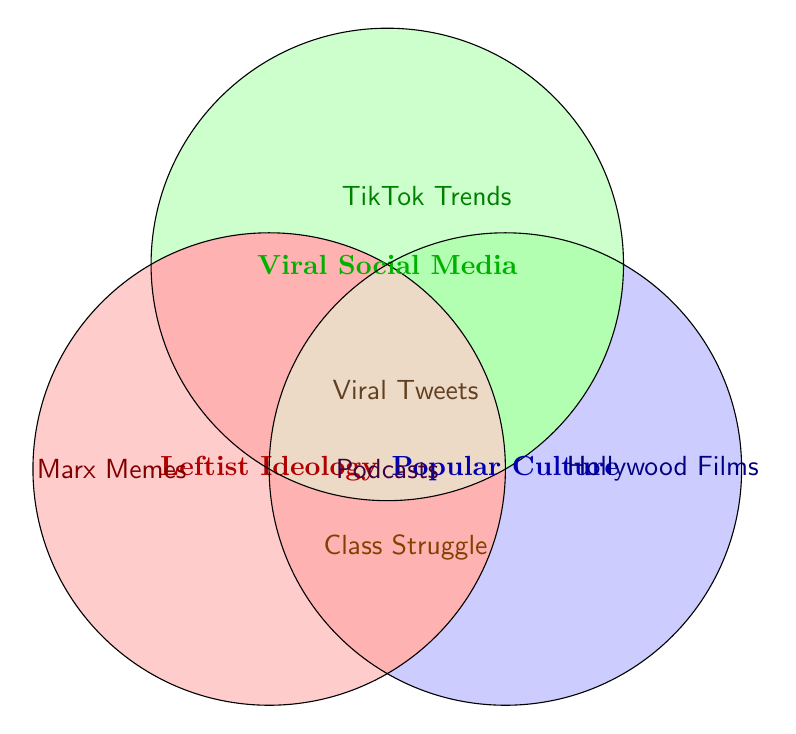What are the three main categories represented in the Venn diagram? The three main categories are labeled directly in the diagram. They are "Leftist Ideology," "Viral Social Media," and "Popular Culture."
Answer: Leftist Ideology, Viral Social Media, Popular Culture Which area in the Venn diagram is associated with "Class Struggle"? The label "Class Struggle" is positioned in the single circle for "Leftist Ideology," indicating it belongs specifically to that category.
Answer: Leftist Ideology What content is found at the intersection of "Leftist Ideology" and "Viral Social Media"? The intersection between the circles for "Leftist Ideology" and "Viral Social Media" is where text related to both labels exists, which is "Viral Tweets."
Answer: Viral Tweets How many elements belong exclusively to the "Popular Culture" circle? The elements only in the "Popular Culture" circle are labeled without overlapping any other circles, which include "Hollywood Films."
Answer: One Which categories intersect with "Podcasts"? The category labels overlapping at the position of "Podcasts" show it is in the intersection of "Viral Social Media" and "Popular Culture."
Answer: Viral Social Media, Popular Culture Find an element in “Popular Culture” that intersects with "Leftist Ideology" but not "Viral Social Media." Only elements positioned where the "Leftist Ideology" and "Popular Culture" circles overlap, without touching the "Viral Social Media" circle apply. There are none labeled in such an intersection in the diagram.
Answer: None Which category contains "TikTok Trends"? The label "TikTok Trends" is positioned within the area for "Viral Social Media," indicating it belongs to that category.
Answer: Viral Social Media Identify all elements that lie at the intersection of all three circles. The area where all three circles intersect contains elements that pertain to all three categories. "Viral Tweets" is positioned in this intersection.
Answer: Viral Tweets 